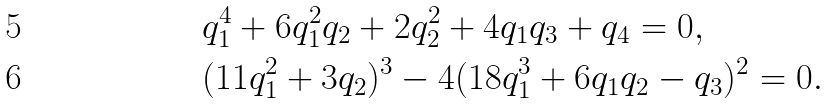Convert formula to latex. <formula><loc_0><loc_0><loc_500><loc_500>& q _ { 1 } ^ { 4 } + 6 q _ { 1 } ^ { 2 } q _ { 2 } + 2 q _ { 2 } ^ { 2 } + 4 q _ { 1 } q _ { 3 } + q _ { 4 } = 0 , \\ & ( 1 1 q _ { 1 } ^ { 2 } + 3 q _ { 2 } ) ^ { 3 } - 4 ( 1 8 q _ { 1 } ^ { 3 } + 6 q _ { 1 } q _ { 2 } - q _ { 3 } ) ^ { 2 } = 0 .</formula> 